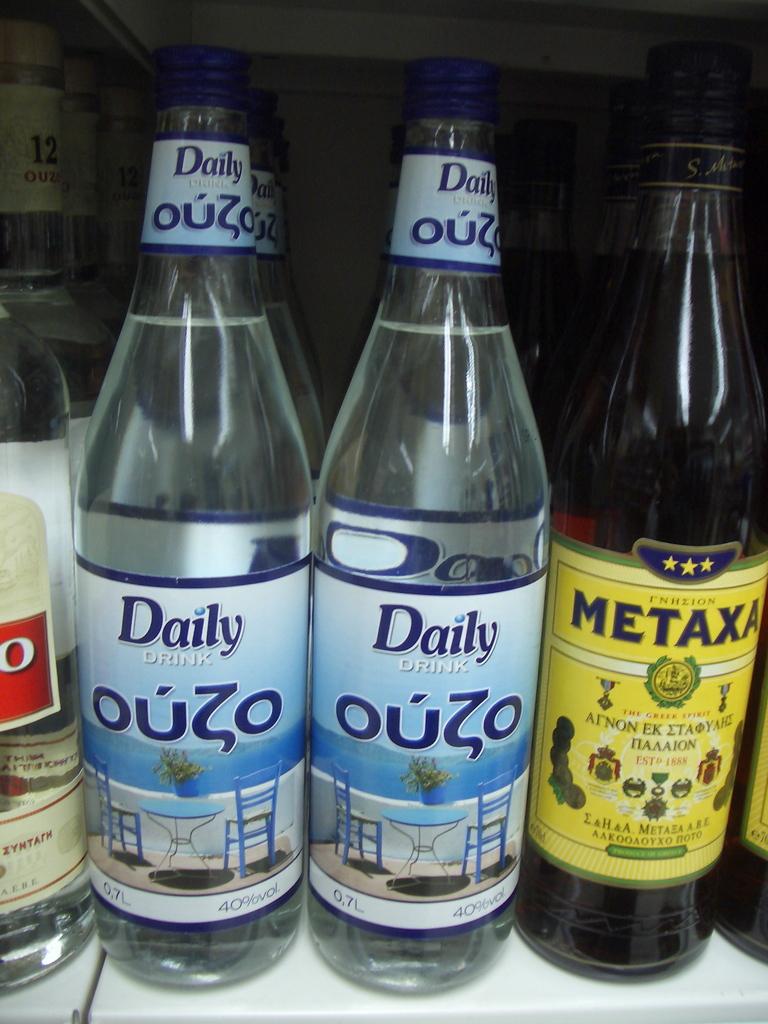What is in the bottles?
Your response must be concise. Ouzo. What is the brand of beverage on the dark bottle?
Offer a terse response. Metaxa. 